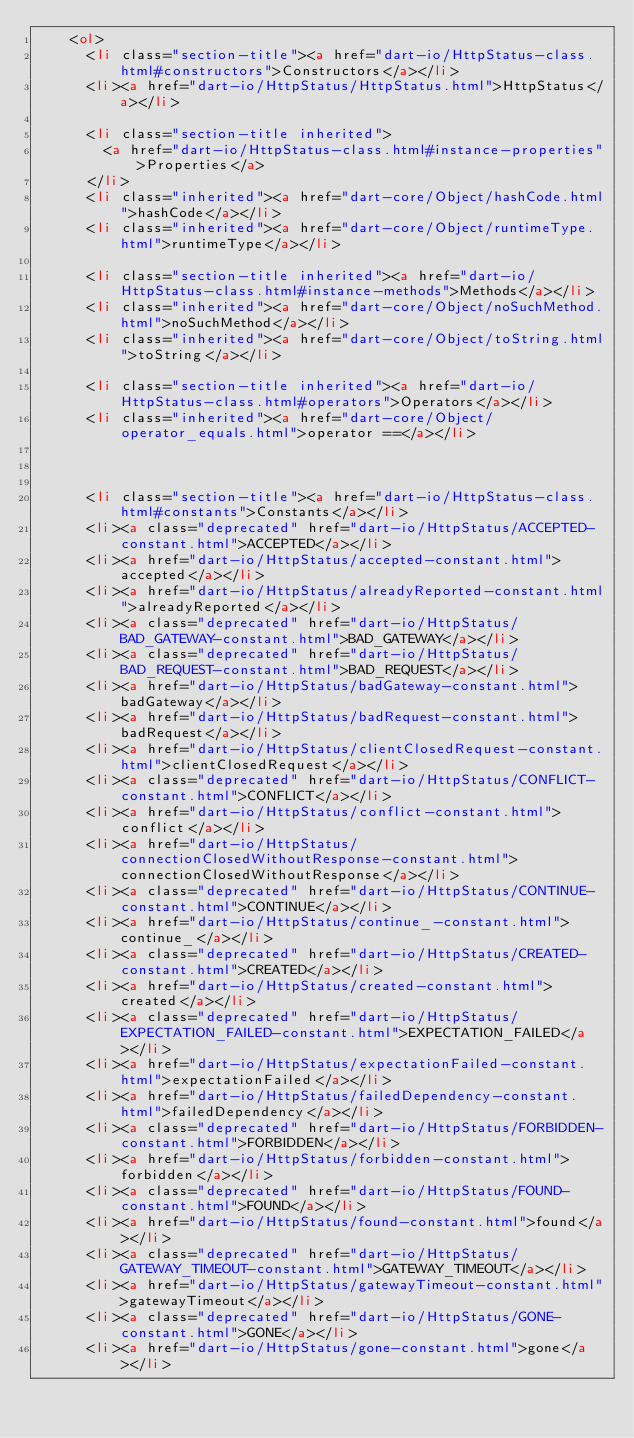<code> <loc_0><loc_0><loc_500><loc_500><_HTML_>    <ol>
      <li class="section-title"><a href="dart-io/HttpStatus-class.html#constructors">Constructors</a></li>
      <li><a href="dart-io/HttpStatus/HttpStatus.html">HttpStatus</a></li>
    
      <li class="section-title inherited">
        <a href="dart-io/HttpStatus-class.html#instance-properties">Properties</a>
      </li>
      <li class="inherited"><a href="dart-core/Object/hashCode.html">hashCode</a></li>
      <li class="inherited"><a href="dart-core/Object/runtimeType.html">runtimeType</a></li>
    
      <li class="section-title inherited"><a href="dart-io/HttpStatus-class.html#instance-methods">Methods</a></li>
      <li class="inherited"><a href="dart-core/Object/noSuchMethod.html">noSuchMethod</a></li>
      <li class="inherited"><a href="dart-core/Object/toString.html">toString</a></li>
    
      <li class="section-title inherited"><a href="dart-io/HttpStatus-class.html#operators">Operators</a></li>
      <li class="inherited"><a href="dart-core/Object/operator_equals.html">operator ==</a></li>
    
    
    
      <li class="section-title"><a href="dart-io/HttpStatus-class.html#constants">Constants</a></li>
      <li><a class="deprecated" href="dart-io/HttpStatus/ACCEPTED-constant.html">ACCEPTED</a></li>
      <li><a href="dart-io/HttpStatus/accepted-constant.html">accepted</a></li>
      <li><a href="dart-io/HttpStatus/alreadyReported-constant.html">alreadyReported</a></li>
      <li><a class="deprecated" href="dart-io/HttpStatus/BAD_GATEWAY-constant.html">BAD_GATEWAY</a></li>
      <li><a class="deprecated" href="dart-io/HttpStatus/BAD_REQUEST-constant.html">BAD_REQUEST</a></li>
      <li><a href="dart-io/HttpStatus/badGateway-constant.html">badGateway</a></li>
      <li><a href="dart-io/HttpStatus/badRequest-constant.html">badRequest</a></li>
      <li><a href="dart-io/HttpStatus/clientClosedRequest-constant.html">clientClosedRequest</a></li>
      <li><a class="deprecated" href="dart-io/HttpStatus/CONFLICT-constant.html">CONFLICT</a></li>
      <li><a href="dart-io/HttpStatus/conflict-constant.html">conflict</a></li>
      <li><a href="dart-io/HttpStatus/connectionClosedWithoutResponse-constant.html">connectionClosedWithoutResponse</a></li>
      <li><a class="deprecated" href="dart-io/HttpStatus/CONTINUE-constant.html">CONTINUE</a></li>
      <li><a href="dart-io/HttpStatus/continue_-constant.html">continue_</a></li>
      <li><a class="deprecated" href="dart-io/HttpStatus/CREATED-constant.html">CREATED</a></li>
      <li><a href="dart-io/HttpStatus/created-constant.html">created</a></li>
      <li><a class="deprecated" href="dart-io/HttpStatus/EXPECTATION_FAILED-constant.html">EXPECTATION_FAILED</a></li>
      <li><a href="dart-io/HttpStatus/expectationFailed-constant.html">expectationFailed</a></li>
      <li><a href="dart-io/HttpStatus/failedDependency-constant.html">failedDependency</a></li>
      <li><a class="deprecated" href="dart-io/HttpStatus/FORBIDDEN-constant.html">FORBIDDEN</a></li>
      <li><a href="dart-io/HttpStatus/forbidden-constant.html">forbidden</a></li>
      <li><a class="deprecated" href="dart-io/HttpStatus/FOUND-constant.html">FOUND</a></li>
      <li><a href="dart-io/HttpStatus/found-constant.html">found</a></li>
      <li><a class="deprecated" href="dart-io/HttpStatus/GATEWAY_TIMEOUT-constant.html">GATEWAY_TIMEOUT</a></li>
      <li><a href="dart-io/HttpStatus/gatewayTimeout-constant.html">gatewayTimeout</a></li>
      <li><a class="deprecated" href="dart-io/HttpStatus/GONE-constant.html">GONE</a></li>
      <li><a href="dart-io/HttpStatus/gone-constant.html">gone</a></li></code> 